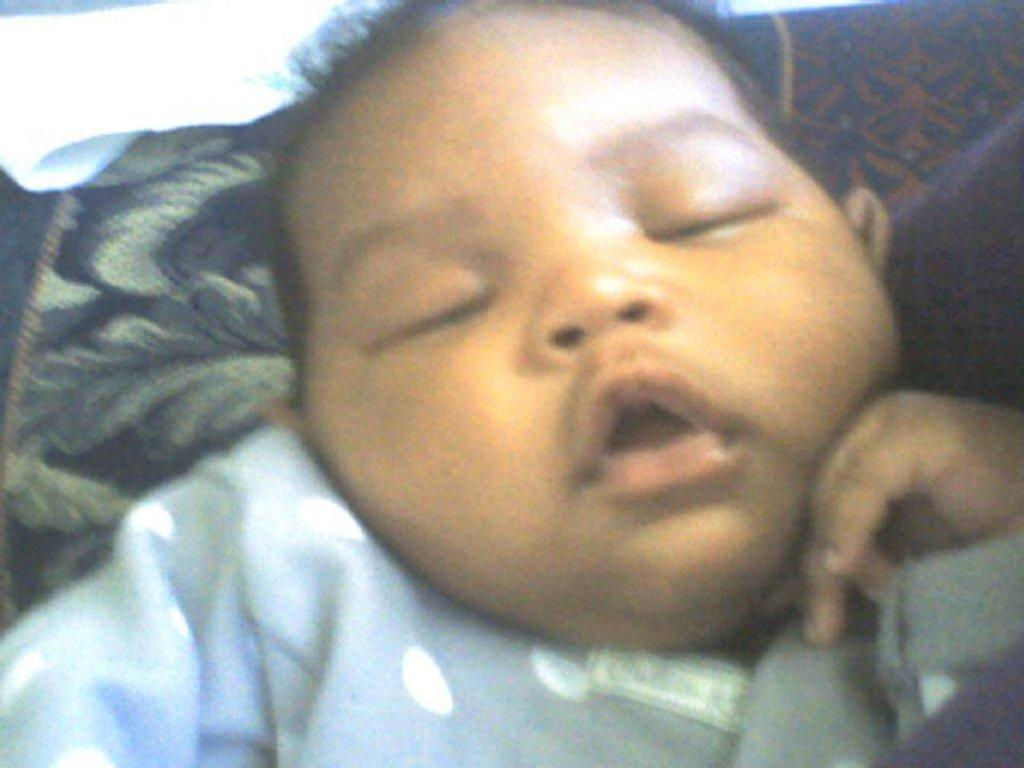What is the main subject of the image? There is a baby in the image. What is the baby doing in the image? The baby is sleeping. What else can be seen in the background of the image? There are clothes visible in the background of the image. Can you tell me how deep the lake is in the image? There is no lake present in the image. What type of liquid is the baby playing with in the image? The baby is sleeping in the image and is not interacting with any liquid. 